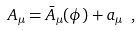Convert formula to latex. <formula><loc_0><loc_0><loc_500><loc_500>A _ { \mu } = \bar { A } _ { \mu } ( \phi ) + a _ { \mu } \ ,</formula> 